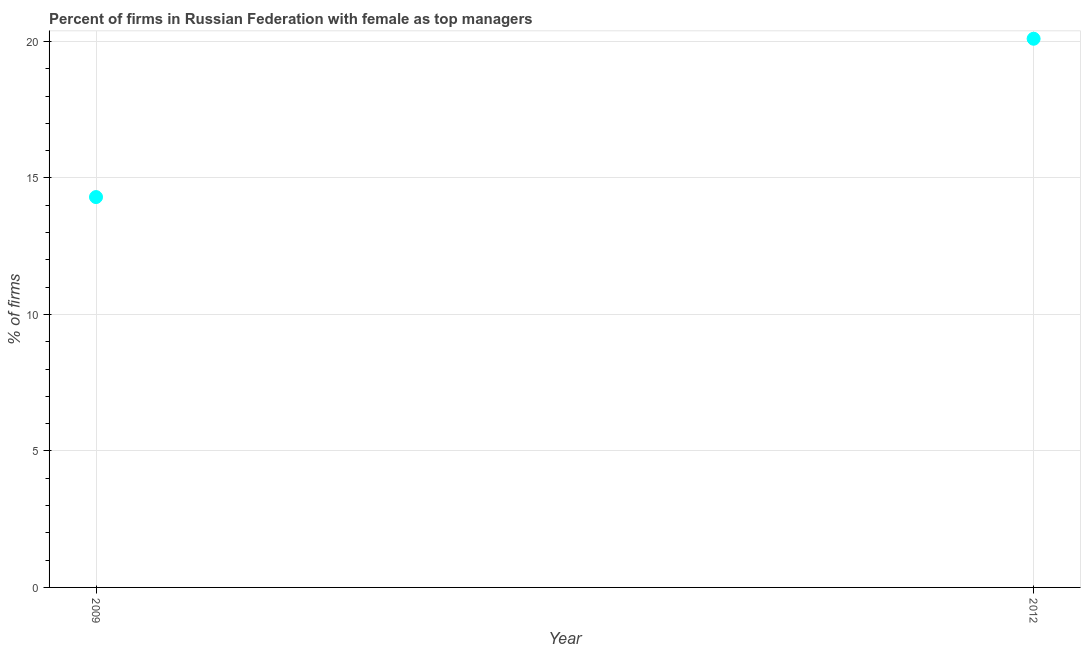What is the percentage of firms with female as top manager in 2012?
Keep it short and to the point. 20.1. Across all years, what is the maximum percentage of firms with female as top manager?
Ensure brevity in your answer.  20.1. In which year was the percentage of firms with female as top manager minimum?
Offer a very short reply. 2009. What is the sum of the percentage of firms with female as top manager?
Give a very brief answer. 34.4. What is the difference between the percentage of firms with female as top manager in 2009 and 2012?
Make the answer very short. -5.8. What is the average percentage of firms with female as top manager per year?
Your answer should be compact. 17.2. What is the median percentage of firms with female as top manager?
Offer a very short reply. 17.2. In how many years, is the percentage of firms with female as top manager greater than 11 %?
Provide a short and direct response. 2. Do a majority of the years between 2012 and 2009 (inclusive) have percentage of firms with female as top manager greater than 4 %?
Your response must be concise. No. What is the ratio of the percentage of firms with female as top manager in 2009 to that in 2012?
Your response must be concise. 0.71. Is the percentage of firms with female as top manager in 2009 less than that in 2012?
Ensure brevity in your answer.  Yes. In how many years, is the percentage of firms with female as top manager greater than the average percentage of firms with female as top manager taken over all years?
Your response must be concise. 1. Does the percentage of firms with female as top manager monotonically increase over the years?
Provide a succinct answer. Yes. How many dotlines are there?
Offer a terse response. 1. How many years are there in the graph?
Keep it short and to the point. 2. What is the difference between two consecutive major ticks on the Y-axis?
Ensure brevity in your answer.  5. Are the values on the major ticks of Y-axis written in scientific E-notation?
Ensure brevity in your answer.  No. Does the graph contain any zero values?
Provide a succinct answer. No. What is the title of the graph?
Give a very brief answer. Percent of firms in Russian Federation with female as top managers. What is the label or title of the X-axis?
Your response must be concise. Year. What is the label or title of the Y-axis?
Your response must be concise. % of firms. What is the % of firms in 2009?
Offer a very short reply. 14.3. What is the % of firms in 2012?
Your answer should be very brief. 20.1. What is the difference between the % of firms in 2009 and 2012?
Your answer should be compact. -5.8. What is the ratio of the % of firms in 2009 to that in 2012?
Make the answer very short. 0.71. 